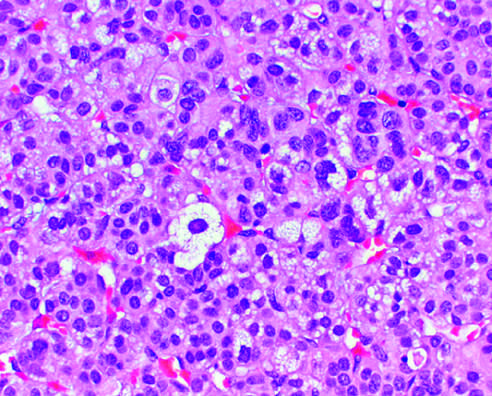s this glandular tumor not seen?
Answer the question using a single word or phrase. No 